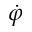Convert formula to latex. <formula><loc_0><loc_0><loc_500><loc_500>\dot { \varphi }</formula> 